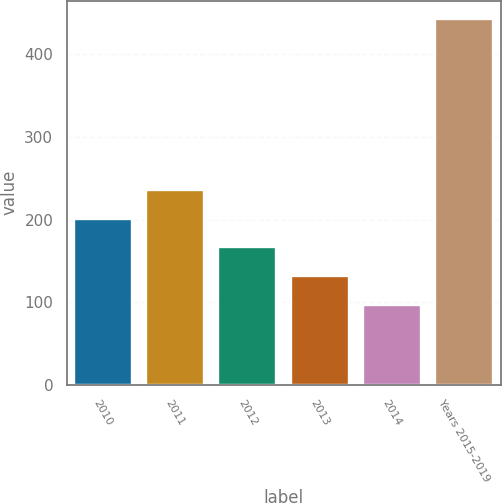<chart> <loc_0><loc_0><loc_500><loc_500><bar_chart><fcel>2010<fcel>2011<fcel>2012<fcel>2013<fcel>2014<fcel>Years 2015-2019<nl><fcel>200.8<fcel>235.4<fcel>166.2<fcel>131.6<fcel>97<fcel>443<nl></chart> 